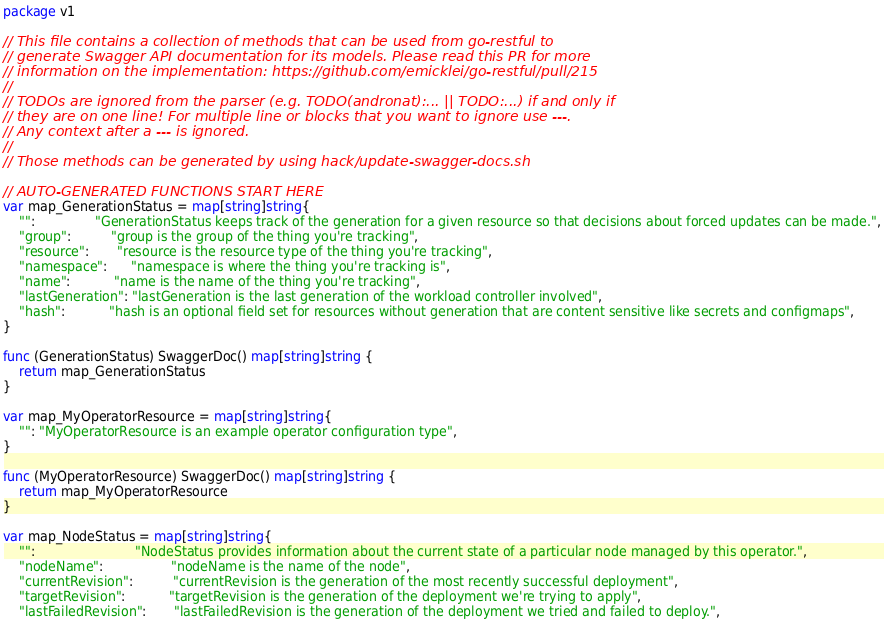<code> <loc_0><loc_0><loc_500><loc_500><_Go_>package v1

// This file contains a collection of methods that can be used from go-restful to
// generate Swagger API documentation for its models. Please read this PR for more
// information on the implementation: https://github.com/emicklei/go-restful/pull/215
//
// TODOs are ignored from the parser (e.g. TODO(andronat):... || TODO:...) if and only if
// they are on one line! For multiple line or blocks that you want to ignore use ---.
// Any context after a --- is ignored.
//
// Those methods can be generated by using hack/update-swagger-docs.sh

// AUTO-GENERATED FUNCTIONS START HERE
var map_GenerationStatus = map[string]string{
	"":               "GenerationStatus keeps track of the generation for a given resource so that decisions about forced updates can be made.",
	"group":          "group is the group of the thing you're tracking",
	"resource":       "resource is the resource type of the thing you're tracking",
	"namespace":      "namespace is where the thing you're tracking is",
	"name":           "name is the name of the thing you're tracking",
	"lastGeneration": "lastGeneration is the last generation of the workload controller involved",
	"hash":           "hash is an optional field set for resources without generation that are content sensitive like secrets and configmaps",
}

func (GenerationStatus) SwaggerDoc() map[string]string {
	return map_GenerationStatus
}

var map_MyOperatorResource = map[string]string{
	"": "MyOperatorResource is an example operator configuration type",
}

func (MyOperatorResource) SwaggerDoc() map[string]string {
	return map_MyOperatorResource
}

var map_NodeStatus = map[string]string{
	"":                         "NodeStatus provides information about the current state of a particular node managed by this operator.",
	"nodeName":                 "nodeName is the name of the node",
	"currentRevision":          "currentRevision is the generation of the most recently successful deployment",
	"targetRevision":           "targetRevision is the generation of the deployment we're trying to apply",
	"lastFailedRevision":       "lastFailedRevision is the generation of the deployment we tried and failed to deploy.",</code> 